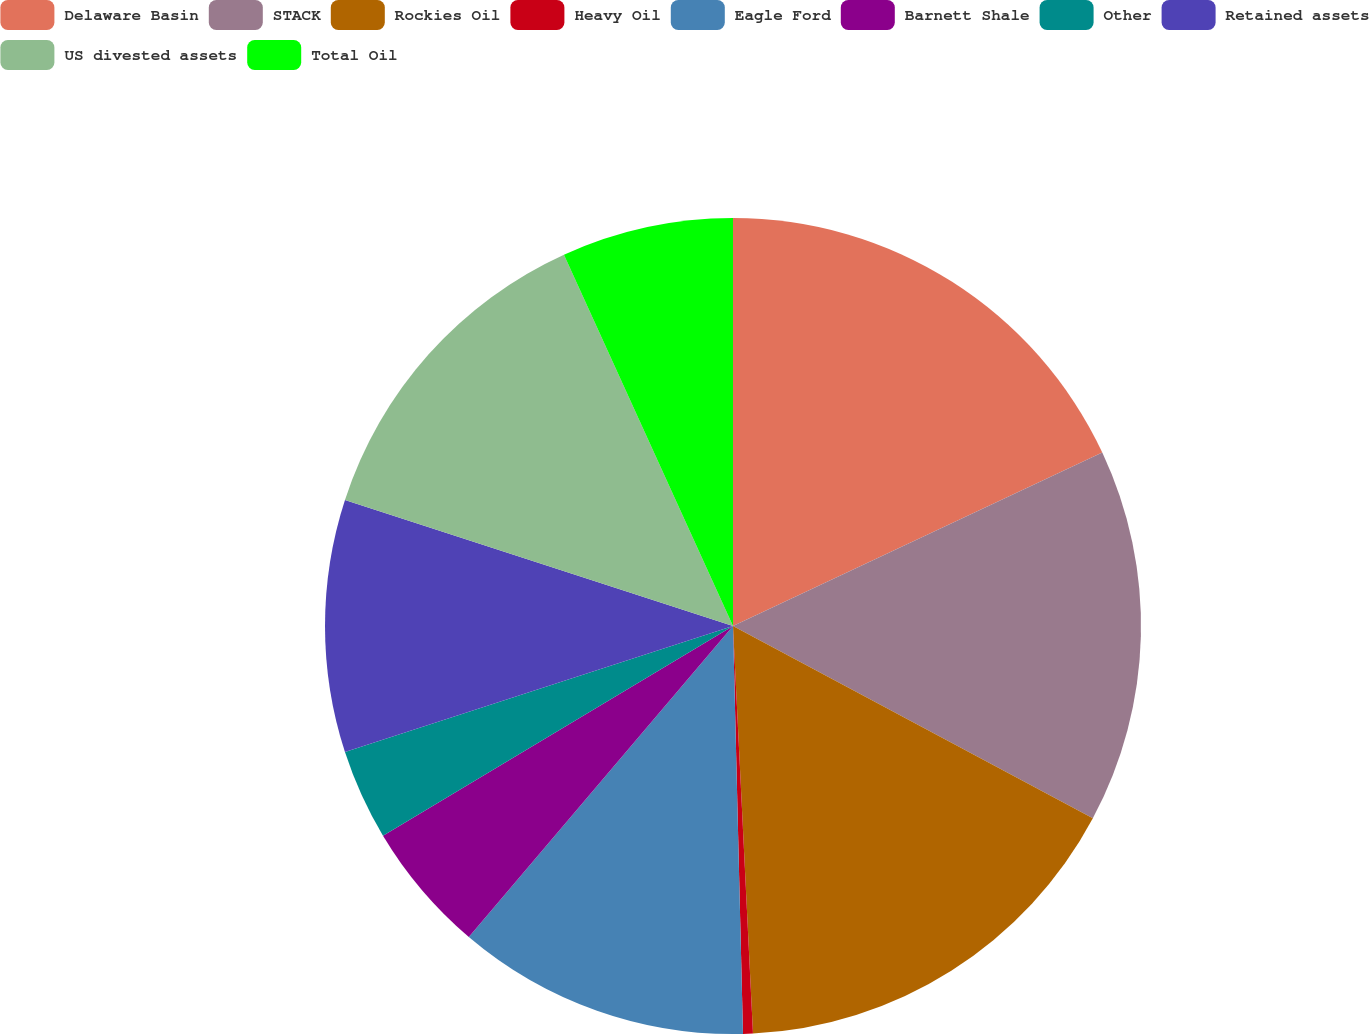<chart> <loc_0><loc_0><loc_500><loc_500><pie_chart><fcel>Delaware Basin<fcel>STACK<fcel>Rockies Oil<fcel>Heavy Oil<fcel>Eagle Ford<fcel>Barnett Shale<fcel>Other<fcel>Retained assets<fcel>US divested assets<fcel>Total Oil<nl><fcel>18.01%<fcel>14.8%<fcel>16.41%<fcel>0.39%<fcel>11.6%<fcel>5.2%<fcel>3.59%<fcel>10.0%<fcel>13.2%<fcel>6.8%<nl></chart> 